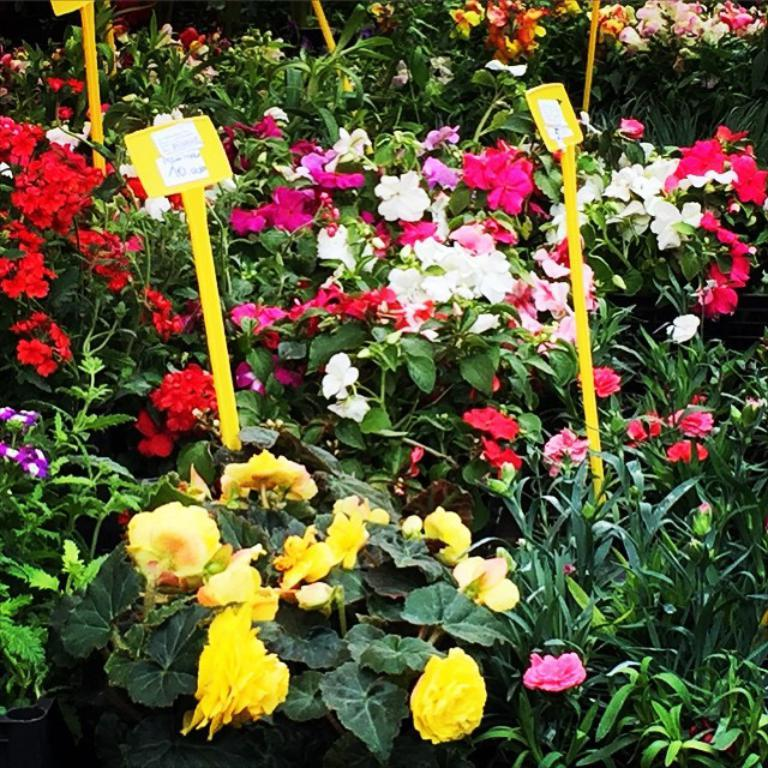What type of living organisms can be seen in the image? Plants can be seen in the image. What colors are the flowers on the plants? The flowers on the plants have different colors, including yellow, white, red, pink, and violet. Are there any additional details about the plants in the image? Yes, there are yellow color tags with prices in the image. Can you tell me how many cords are connected to the goose in the image? There is no goose present in the image, and therefore no cords connected to it. 